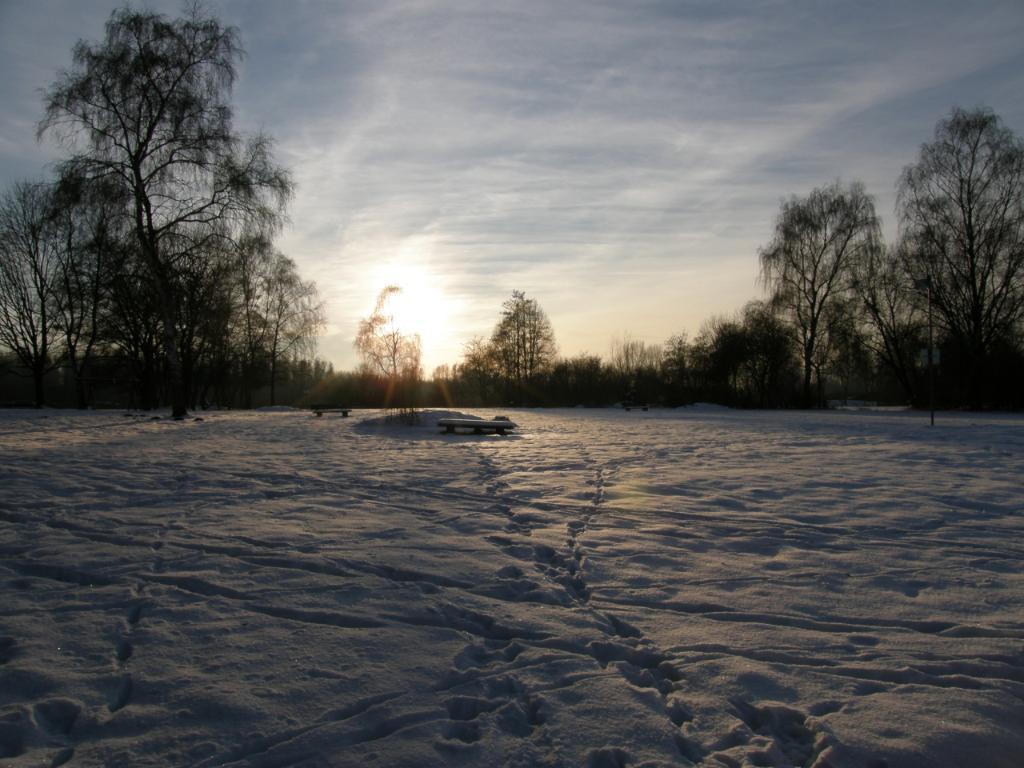In one or two sentences, can you explain what this image depicts? In this image I can see ground full of snow. In the background I can see number of trees and the sky. 